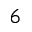<formula> <loc_0><loc_0><loc_500><loc_500>6</formula> 